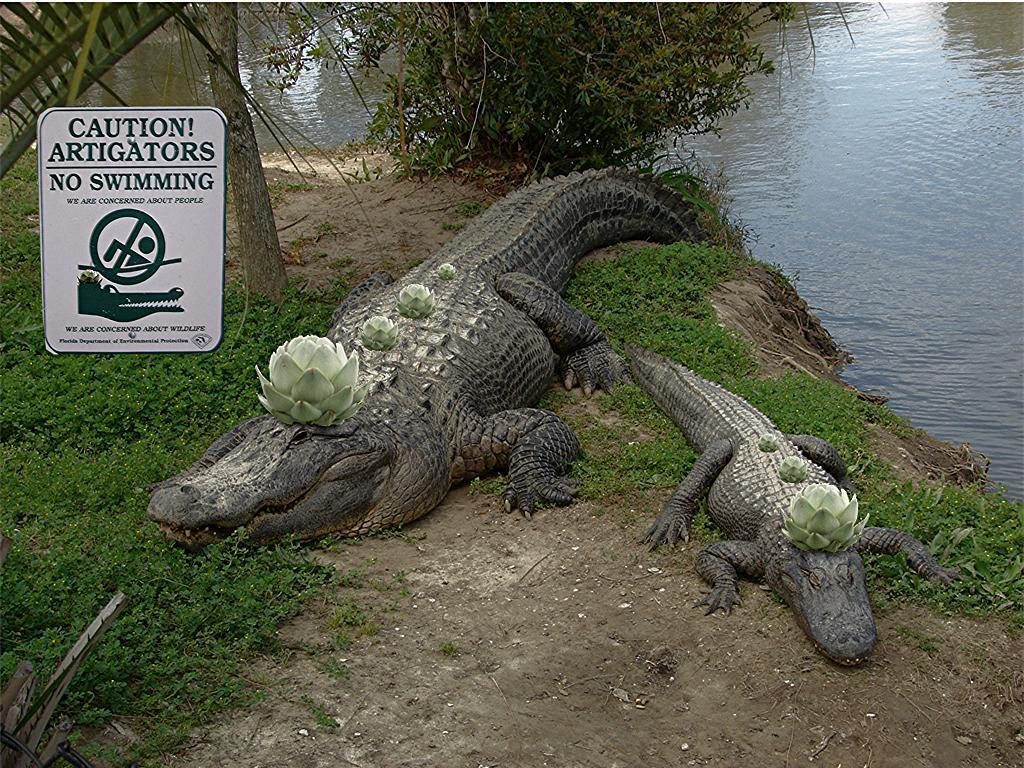What animals can be seen on the ground in the image? There are alligators on the ground in the image. What kind of informational or directional sign is present in the image? There is a sign board in the image. What body of water is visible in the image? There is a lake in the image. What type of vegetation can be seen in the image? There is a tree and plants in the image. What type of ground cover is present in the image? There is grass in the image. What type of powder is being used to create the example sweater in the image? There is no powder, example, or sweater present in the image. 